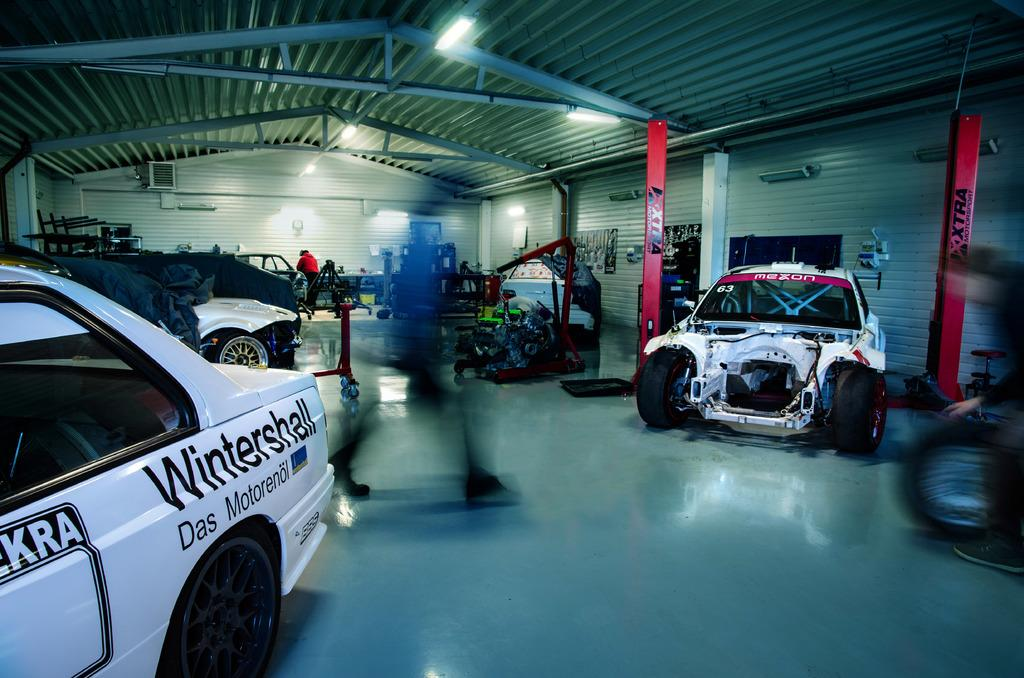What type of objects can be found inside the shed? There are vehicles and people inside the shed. What are the people doing inside the shed? The people are in motion, suggesting they might be working or moving around. What can be used for illumination inside the shed? There are lights visible in the shed. Can you describe any other items present in the shed? There are other unspecified things present in the shed. What type of bone can be seen inside the shed? There is no bone present inside the shed. What liquid is being used to clean the vehicles in the shed? There is no mention of any liquid being used to clean the vehicles in the shed. 